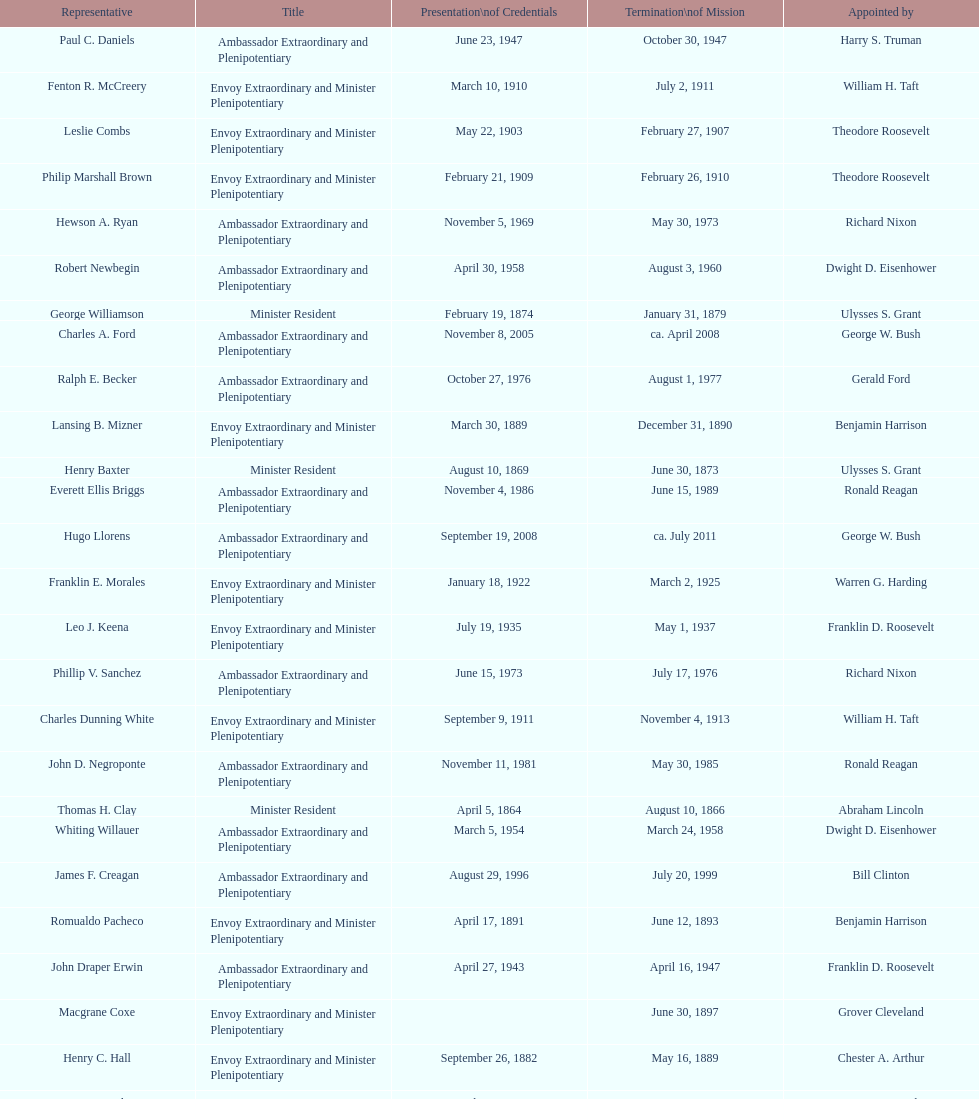Is solon borland a representative? Yes. 